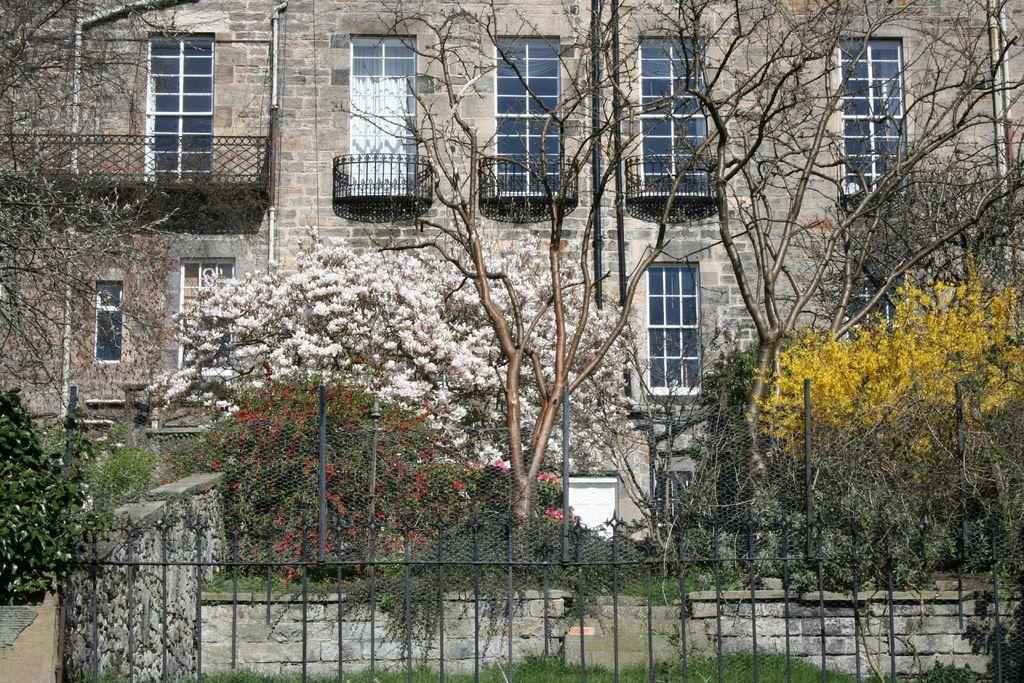What type of structure is visible in the image? There is a building in the image. What feature can be seen on the building? The building has windows. What is located in front of the building? There are trees and plants in front of the building. What is at the bottom of the image? There is fencing at the bottom of the image. What type of wool is being used to copy the building in the image? There is no wool or copying process present in the image; it simply shows a building with windows, trees, plants, and fencing. 